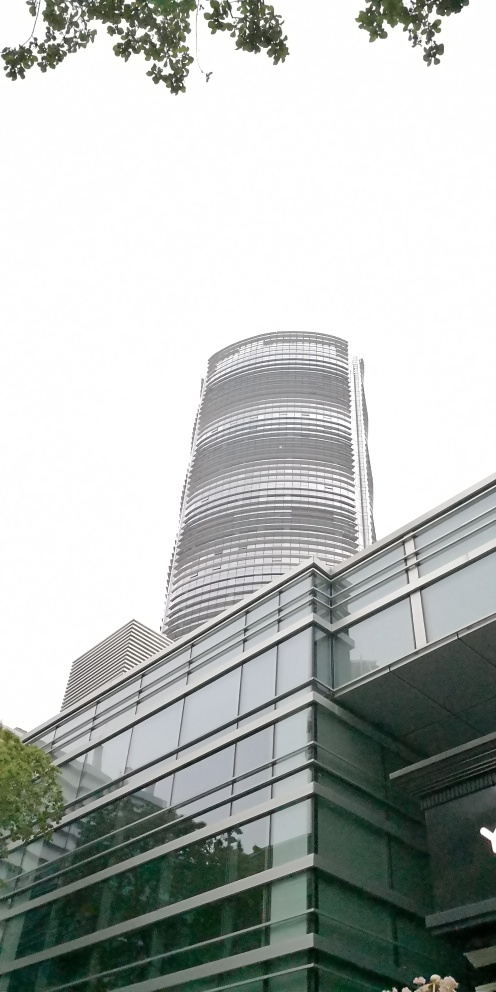What architectural style does the office building in the photo represent? The office building exhibits elements of modern architectural design, characterized by its use of sleek, reflective glass surfaces and a strong, cylindrical vertical form that suggests a contemporary and forward-thinking approach to architecture. 